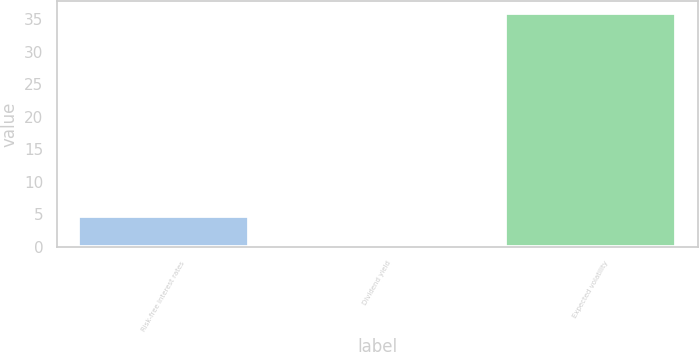<chart> <loc_0><loc_0><loc_500><loc_500><bar_chart><fcel>Risk-free interest rates<fcel>Dividend yield<fcel>Expected volatility<nl><fcel>4.7<fcel>0.14<fcel>36<nl></chart> 